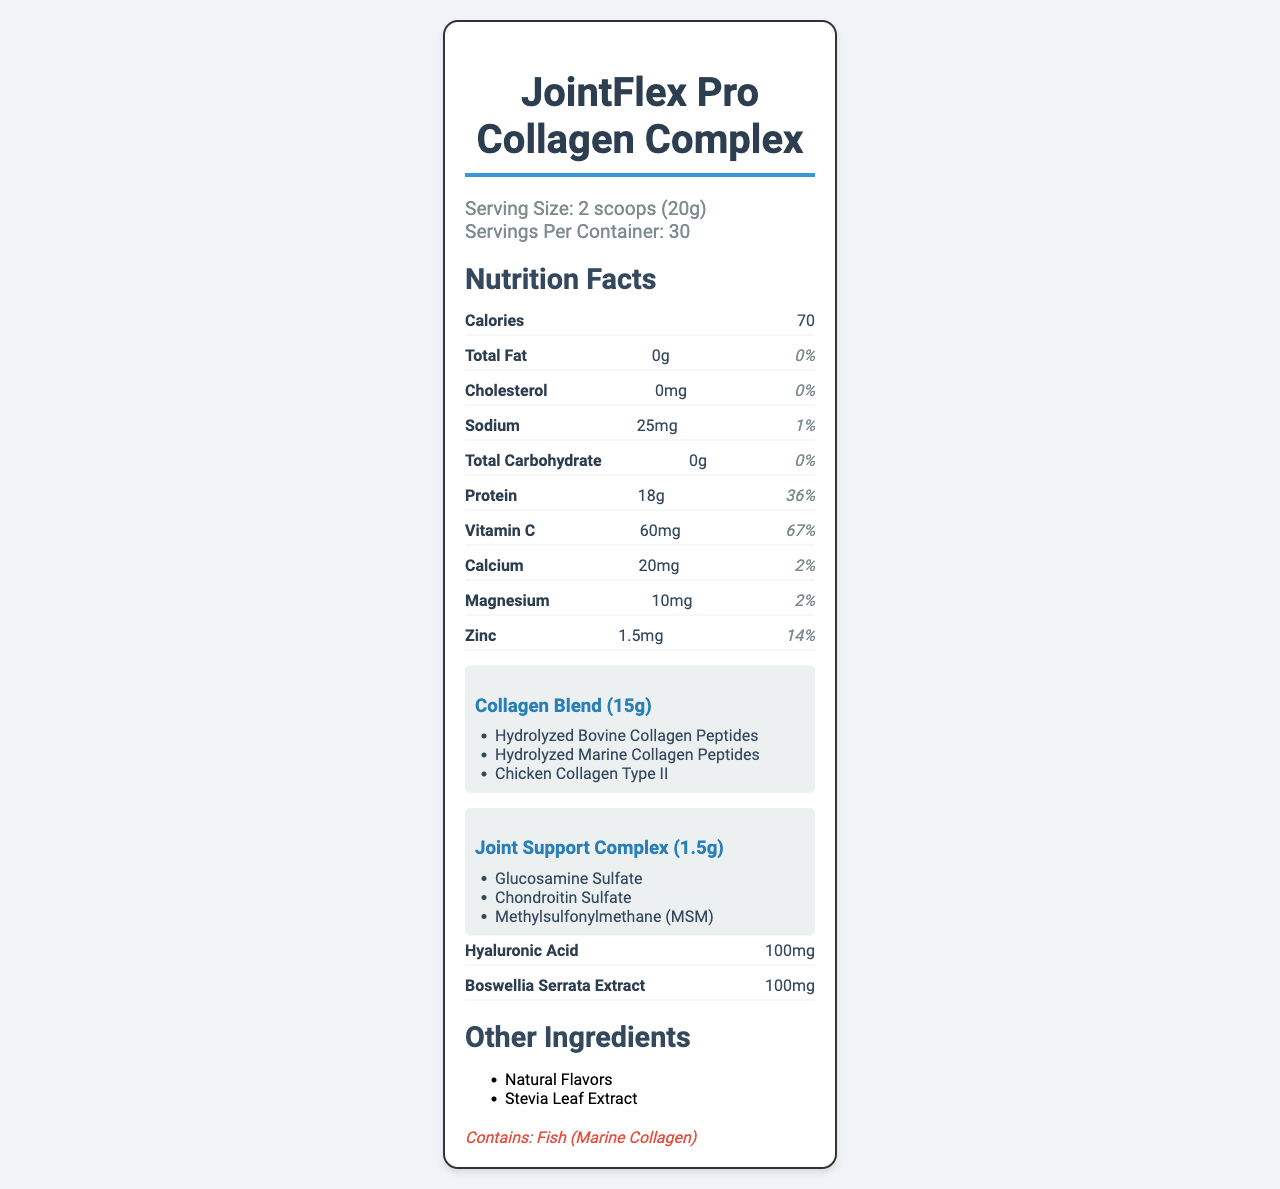What is the product name? The product name is clearly displayed at the top and in the title of the document.
Answer: JointFlex Pro Collagen Complex How many servings are there per container? According to the serving information, there are 30 servings per container.
Answer: 30 What is the serving size? The document specifies that the serving size is 2 scoops, which equals 20 grams.
Answer: 2 scoops (20g) How many calories are there per serving? The calories per serving are listed as 70.
Answer: 70 What is the amount of sodium per serving? The document states that each serving contains 25mg of sodium.
Answer: 25mg Which ingredient in the Collagen Blend is derived from fish? A. Hydrolyzed Bovine Collagen Peptides B. Hydrolyzed Marine Collagen Peptides C. Chicken Collagen Type II The allergen information mentions that the product contains fish, which is found in Marine Collagen.
Answer: B What percentage of the daily value of Vitamin C is provided per serving? A. 50% B. 67% C. 100% The daily value percentage for Vitamin C per serving is listed as 67%.
Answer: B Does this product contain any cholesterol? The cholesterol amount is 0mg, which is 0% of the daily value, indicating no cholesterol.
Answer: No Which of the following is NOT an ingredient in the Joint Support Complex? A. Glucosamine Sulfate B. Chondroitin Sulfate C. Hyaluronic Acid Hyaluronic Acid is listed separately with its own amount and is not part of the Joint Support Complex.
Answer: C Summarize the main components of the "JointFlex Pro Collagen Complex". The document provides a detailed list of ingredients and nutritional information, focusing on components beneficial for joint health and cartilage repair.
Answer: The "JointFlex Pro Collagen Complex" is a supplement designed for joint health and cartilage repair. It contains a collagen blend (15g) with Hydrolyzed Bovine Collagen Peptides, Hydrolyzed Marine Collagen Peptides, and Chicken Collagen Type II. It also has a Joint Support Complex (1.5g) including Glucosamine Sulfate, Chondroitin Sulfate, and MSM. Additionally, it contains Hyaluronic Acid, Boswellia Serrata Extract, Vitamin C, Calcium, Magnesium, and Zinc, with natural flavors and Stevia Leaf Extract. What is the main purpose of this supplement? The product is rich in collagen and joint-supporting components, indicating its primary use for joint health and cartilage repair.
Answer: Joint health and cartilage repair Is this product suitable for someone allergic to fish? The allergen information clearly states that the product contains fish due to the Marine Collagen.
Answer: No How much protein does one serving of the supplement contain? The document indicates that one serving contains 18 grams of protein.
Answer: 18g List the ingredients found in the Joint Support Complex. The Joint Support Complex includes these three ingredients as listed in the document.
Answer: Glucosamine Sulfate, Chondroitin Sulfate, Methylsulfonylmethane (MSM) Which mineral, at its given amount, provides the highest daily value percentage? Zinc is provided in an amount of 1.5mg, which accounts for 14% of the daily value, the highest among the listed minerals.
Answer: Zinc Is the detailed manufacturing process of the collagen blend provided? The document specifies the ingredients but does not provide any manufacturing process details.
Answer: Cannot be determined 